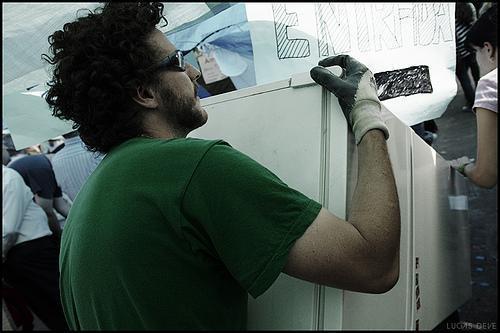How many magnets can be seen on the fridge?
Give a very brief answer. 5. 